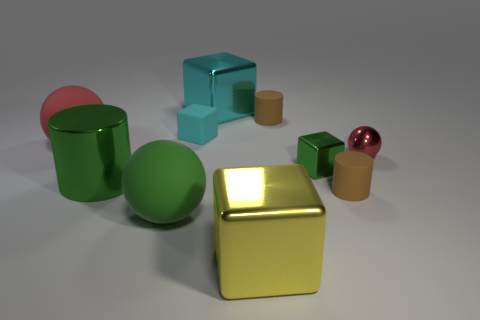If we assume the largest cube is made of gold, what can we infer about the scene in terms of realism? If the largest cube is indeed gold, its sheen and reflection have been rendered realistically, giving the scene a semblance of authenticity. However, the perfect shapes and uniform colors of the objects suggest a digitally created or staged setup, rather than a naturally occurring one. 